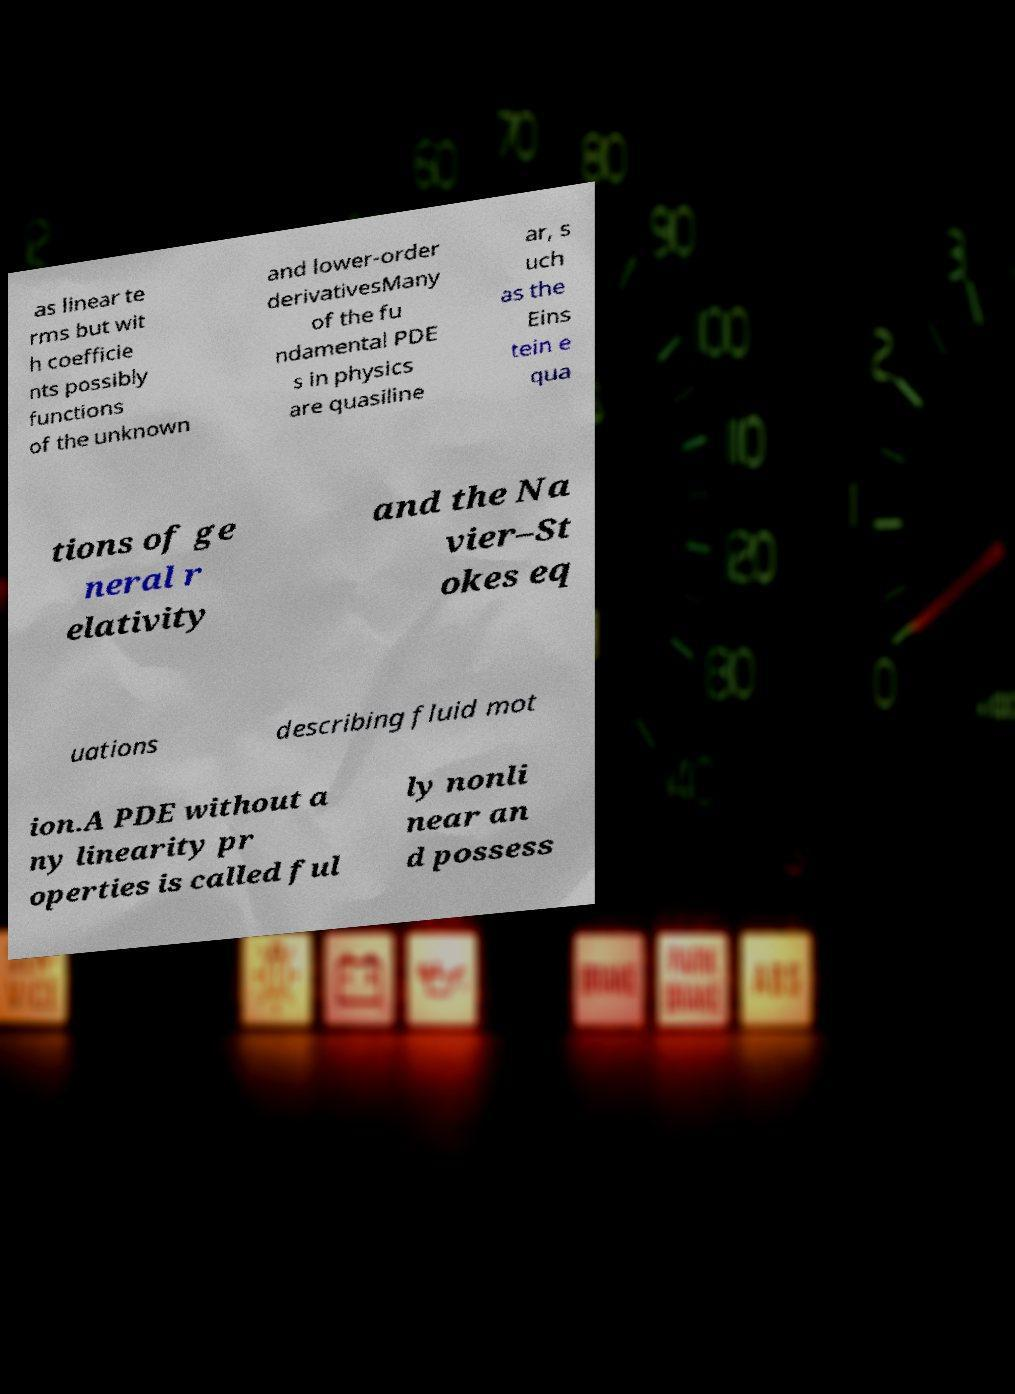Could you extract and type out the text from this image? as linear te rms but wit h coefficie nts possibly functions of the unknown and lower-order derivativesMany of the fu ndamental PDE s in physics are quasiline ar, s uch as the Eins tein e qua tions of ge neral r elativity and the Na vier–St okes eq uations describing fluid mot ion.A PDE without a ny linearity pr operties is called ful ly nonli near an d possess 